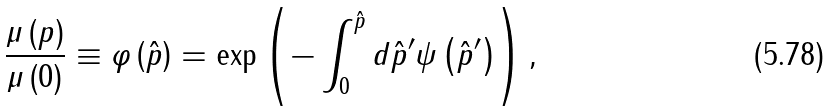<formula> <loc_0><loc_0><loc_500><loc_500>\frac { \mu \left ( p \right ) } { \mu \left ( 0 \right ) } \equiv \varphi \left ( \hat { p } \right ) = \exp \left ( - \int _ { 0 } ^ { \hat { p } } d { \hat { p } ^ { \prime } } \psi \left ( \hat { p } ^ { \prime } \right ) \right ) ,</formula> 